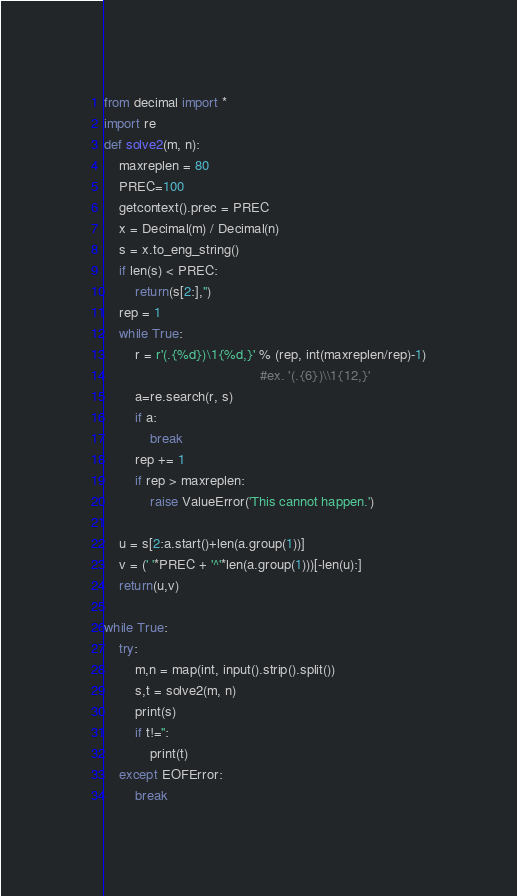<code> <loc_0><loc_0><loc_500><loc_500><_Python_>from decimal import *
import re
def solve2(m, n):
    maxreplen = 80
    PREC=100
    getcontext().prec = PREC
    x = Decimal(m) / Decimal(n)
    s = x.to_eng_string()
    if len(s) < PREC:
        return(s[2:],'')
    rep = 1
    while True:
        r = r'(.{%d})\1{%d,}' % (rep, int(maxreplen/rep)-1)
                                         #ex. '(.{6})\\1{12,}'
        a=re.search(r, s)
        if a:
            break
        rep += 1
        if rep > maxreplen:
            raise ValueError('This cannot happen.')

    u = s[2:a.start()+len(a.group(1))]
    v = (' '*PREC + '^'*len(a.group(1)))[-len(u):]
    return(u,v)

while True:
    try:
        m,n = map(int, input().strip().split())
        s,t = solve2(m, n)
        print(s)
        if t!='':
            print(t)
    except EOFError:
        break</code> 